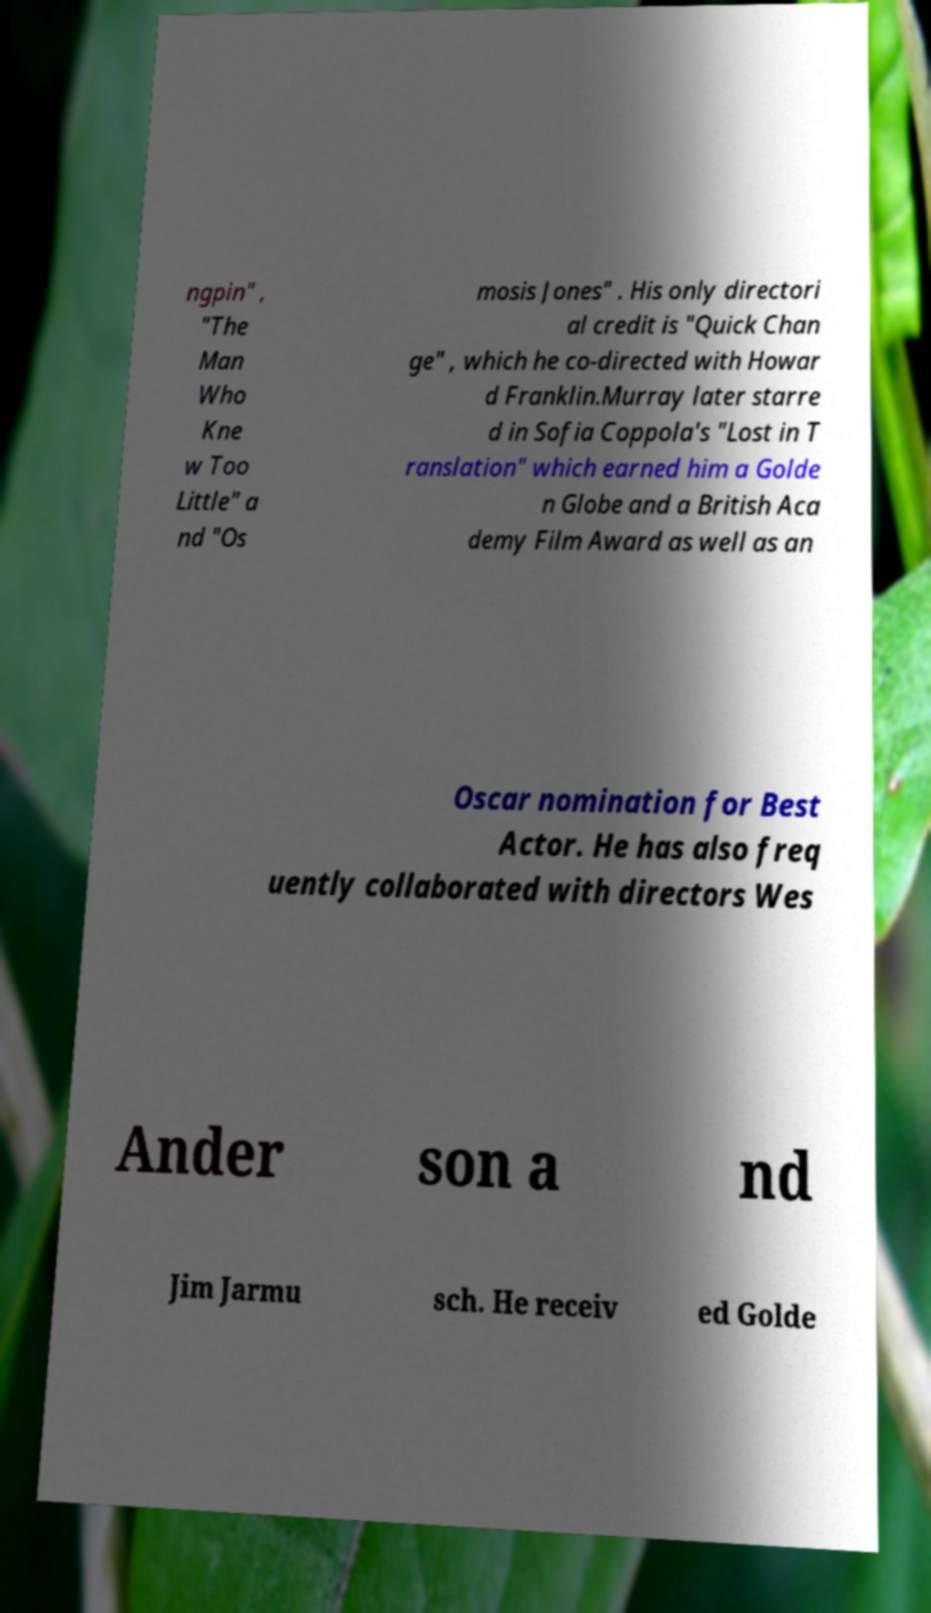Could you extract and type out the text from this image? ngpin" , "The Man Who Kne w Too Little" a nd "Os mosis Jones" . His only directori al credit is "Quick Chan ge" , which he co-directed with Howar d Franklin.Murray later starre d in Sofia Coppola's "Lost in T ranslation" which earned him a Golde n Globe and a British Aca demy Film Award as well as an Oscar nomination for Best Actor. He has also freq uently collaborated with directors Wes Ander son a nd Jim Jarmu sch. He receiv ed Golde 